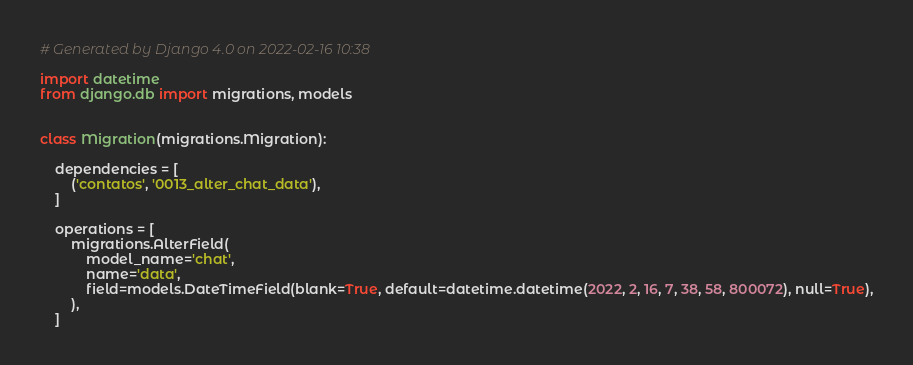<code> <loc_0><loc_0><loc_500><loc_500><_Python_># Generated by Django 4.0 on 2022-02-16 10:38

import datetime
from django.db import migrations, models


class Migration(migrations.Migration):

    dependencies = [
        ('contatos', '0013_alter_chat_data'),
    ]

    operations = [
        migrations.AlterField(
            model_name='chat',
            name='data',
            field=models.DateTimeField(blank=True, default=datetime.datetime(2022, 2, 16, 7, 38, 58, 800072), null=True),
        ),
    ]
</code> 